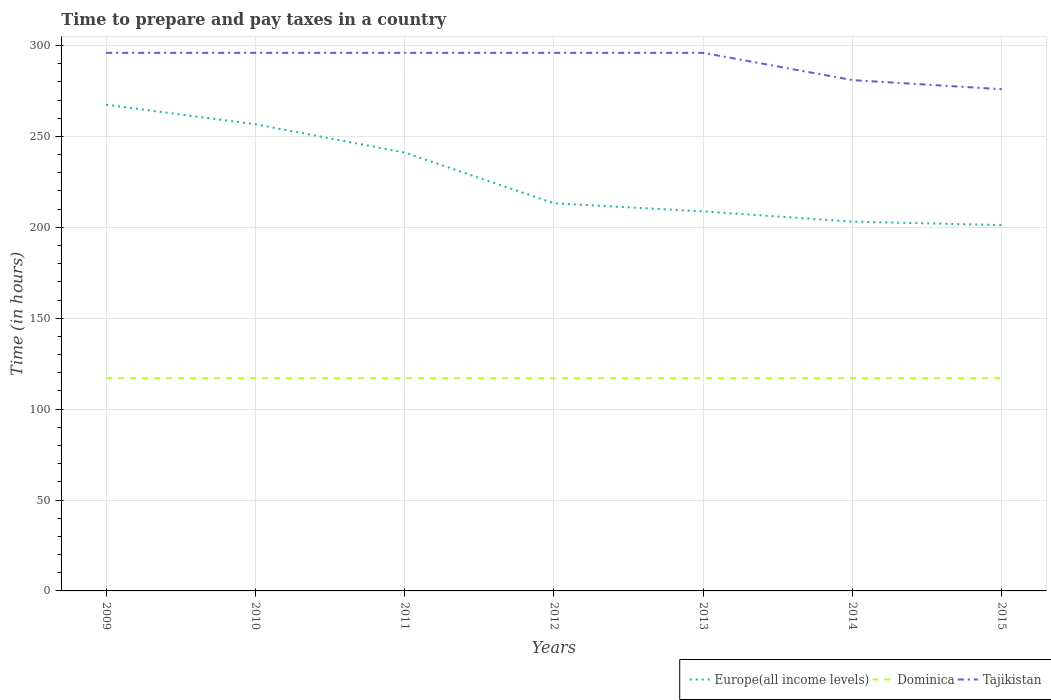How many different coloured lines are there?
Your answer should be very brief. 3. Does the line corresponding to Tajikistan intersect with the line corresponding to Dominica?
Your response must be concise. No. Across all years, what is the maximum number of hours required to prepare and pay taxes in Europe(all income levels)?
Your answer should be compact. 201.25. In which year was the number of hours required to prepare and pay taxes in Europe(all income levels) maximum?
Offer a terse response. 2015. What is the total number of hours required to prepare and pay taxes in Tajikistan in the graph?
Your response must be concise. 20. What is the difference between the highest and the second highest number of hours required to prepare and pay taxes in Tajikistan?
Make the answer very short. 20. How many lines are there?
Your answer should be compact. 3. Are the values on the major ticks of Y-axis written in scientific E-notation?
Your answer should be compact. No. Where does the legend appear in the graph?
Your answer should be very brief. Bottom right. What is the title of the graph?
Make the answer very short. Time to prepare and pay taxes in a country. What is the label or title of the X-axis?
Your answer should be compact. Years. What is the label or title of the Y-axis?
Make the answer very short. Time (in hours). What is the Time (in hours) of Europe(all income levels) in 2009?
Give a very brief answer. 267.45. What is the Time (in hours) of Dominica in 2009?
Give a very brief answer. 117. What is the Time (in hours) in Tajikistan in 2009?
Offer a very short reply. 296. What is the Time (in hours) of Europe(all income levels) in 2010?
Your response must be concise. 256.72. What is the Time (in hours) of Dominica in 2010?
Offer a very short reply. 117. What is the Time (in hours) in Tajikistan in 2010?
Ensure brevity in your answer.  296. What is the Time (in hours) in Europe(all income levels) in 2011?
Provide a short and direct response. 241.15. What is the Time (in hours) of Dominica in 2011?
Make the answer very short. 117. What is the Time (in hours) of Tajikistan in 2011?
Your response must be concise. 296. What is the Time (in hours) in Europe(all income levels) in 2012?
Offer a very short reply. 213.24. What is the Time (in hours) in Dominica in 2012?
Your answer should be compact. 117. What is the Time (in hours) in Tajikistan in 2012?
Your answer should be compact. 296. What is the Time (in hours) of Europe(all income levels) in 2013?
Your response must be concise. 208.78. What is the Time (in hours) in Dominica in 2013?
Your answer should be compact. 117. What is the Time (in hours) of Tajikistan in 2013?
Offer a very short reply. 296. What is the Time (in hours) in Europe(all income levels) in 2014?
Provide a succinct answer. 203.14. What is the Time (in hours) of Dominica in 2014?
Your answer should be very brief. 117. What is the Time (in hours) in Tajikistan in 2014?
Your answer should be compact. 281. What is the Time (in hours) of Europe(all income levels) in 2015?
Provide a short and direct response. 201.25. What is the Time (in hours) of Dominica in 2015?
Provide a succinct answer. 117. What is the Time (in hours) of Tajikistan in 2015?
Ensure brevity in your answer.  276. Across all years, what is the maximum Time (in hours) of Europe(all income levels)?
Provide a succinct answer. 267.45. Across all years, what is the maximum Time (in hours) of Dominica?
Give a very brief answer. 117. Across all years, what is the maximum Time (in hours) of Tajikistan?
Your response must be concise. 296. Across all years, what is the minimum Time (in hours) of Europe(all income levels)?
Provide a succinct answer. 201.25. Across all years, what is the minimum Time (in hours) in Dominica?
Offer a terse response. 117. Across all years, what is the minimum Time (in hours) in Tajikistan?
Ensure brevity in your answer.  276. What is the total Time (in hours) of Europe(all income levels) in the graph?
Provide a short and direct response. 1591.73. What is the total Time (in hours) in Dominica in the graph?
Provide a short and direct response. 819. What is the total Time (in hours) of Tajikistan in the graph?
Give a very brief answer. 2037. What is the difference between the Time (in hours) of Europe(all income levels) in 2009 and that in 2010?
Your response must be concise. 10.73. What is the difference between the Time (in hours) of Tajikistan in 2009 and that in 2010?
Provide a short and direct response. 0. What is the difference between the Time (in hours) in Europe(all income levels) in 2009 and that in 2011?
Your response must be concise. 26.3. What is the difference between the Time (in hours) in Dominica in 2009 and that in 2011?
Offer a terse response. 0. What is the difference between the Time (in hours) in Tajikistan in 2009 and that in 2011?
Make the answer very short. 0. What is the difference between the Time (in hours) of Europe(all income levels) in 2009 and that in 2012?
Give a very brief answer. 54.21. What is the difference between the Time (in hours) in Dominica in 2009 and that in 2012?
Ensure brevity in your answer.  0. What is the difference between the Time (in hours) in Tajikistan in 2009 and that in 2012?
Ensure brevity in your answer.  0. What is the difference between the Time (in hours) in Europe(all income levels) in 2009 and that in 2013?
Provide a succinct answer. 58.68. What is the difference between the Time (in hours) in Dominica in 2009 and that in 2013?
Your answer should be very brief. 0. What is the difference between the Time (in hours) in Tajikistan in 2009 and that in 2013?
Your answer should be compact. 0. What is the difference between the Time (in hours) in Europe(all income levels) in 2009 and that in 2014?
Provide a short and direct response. 64.31. What is the difference between the Time (in hours) in Dominica in 2009 and that in 2014?
Offer a very short reply. 0. What is the difference between the Time (in hours) of Tajikistan in 2009 and that in 2014?
Offer a very short reply. 15. What is the difference between the Time (in hours) in Europe(all income levels) in 2009 and that in 2015?
Keep it short and to the point. 66.2. What is the difference between the Time (in hours) of Dominica in 2009 and that in 2015?
Your response must be concise. 0. What is the difference between the Time (in hours) in Europe(all income levels) in 2010 and that in 2011?
Your response must be concise. 15.57. What is the difference between the Time (in hours) in Europe(all income levels) in 2010 and that in 2012?
Keep it short and to the point. 43.48. What is the difference between the Time (in hours) in Tajikistan in 2010 and that in 2012?
Keep it short and to the point. 0. What is the difference between the Time (in hours) in Europe(all income levels) in 2010 and that in 2013?
Offer a very short reply. 47.95. What is the difference between the Time (in hours) of Dominica in 2010 and that in 2013?
Keep it short and to the point. 0. What is the difference between the Time (in hours) of Europe(all income levels) in 2010 and that in 2014?
Give a very brief answer. 53.58. What is the difference between the Time (in hours) in Dominica in 2010 and that in 2014?
Your response must be concise. 0. What is the difference between the Time (in hours) of Europe(all income levels) in 2010 and that in 2015?
Offer a very short reply. 55.47. What is the difference between the Time (in hours) of Dominica in 2010 and that in 2015?
Your response must be concise. 0. What is the difference between the Time (in hours) of Tajikistan in 2010 and that in 2015?
Your answer should be compact. 20. What is the difference between the Time (in hours) in Europe(all income levels) in 2011 and that in 2012?
Offer a terse response. 27.91. What is the difference between the Time (in hours) in Dominica in 2011 and that in 2012?
Your response must be concise. 0. What is the difference between the Time (in hours) of Europe(all income levels) in 2011 and that in 2013?
Offer a very short reply. 32.37. What is the difference between the Time (in hours) in Dominica in 2011 and that in 2013?
Your answer should be compact. 0. What is the difference between the Time (in hours) in Tajikistan in 2011 and that in 2013?
Ensure brevity in your answer.  0. What is the difference between the Time (in hours) of Europe(all income levels) in 2011 and that in 2014?
Provide a short and direct response. 38.01. What is the difference between the Time (in hours) of Europe(all income levels) in 2011 and that in 2015?
Ensure brevity in your answer.  39.9. What is the difference between the Time (in hours) in Dominica in 2011 and that in 2015?
Provide a short and direct response. 0. What is the difference between the Time (in hours) of Tajikistan in 2011 and that in 2015?
Keep it short and to the point. 20. What is the difference between the Time (in hours) in Europe(all income levels) in 2012 and that in 2013?
Provide a succinct answer. 4.46. What is the difference between the Time (in hours) of Tajikistan in 2012 and that in 2013?
Your answer should be very brief. 0. What is the difference between the Time (in hours) of Europe(all income levels) in 2012 and that in 2014?
Provide a short and direct response. 10.1. What is the difference between the Time (in hours) in Dominica in 2012 and that in 2014?
Keep it short and to the point. 0. What is the difference between the Time (in hours) in Tajikistan in 2012 and that in 2014?
Offer a terse response. 15. What is the difference between the Time (in hours) of Europe(all income levels) in 2012 and that in 2015?
Make the answer very short. 11.99. What is the difference between the Time (in hours) of Dominica in 2012 and that in 2015?
Your response must be concise. 0. What is the difference between the Time (in hours) of Tajikistan in 2012 and that in 2015?
Your answer should be compact. 20. What is the difference between the Time (in hours) of Europe(all income levels) in 2013 and that in 2014?
Give a very brief answer. 5.63. What is the difference between the Time (in hours) in Tajikistan in 2013 and that in 2014?
Provide a succinct answer. 15. What is the difference between the Time (in hours) of Europe(all income levels) in 2013 and that in 2015?
Your answer should be compact. 7.52. What is the difference between the Time (in hours) in Dominica in 2013 and that in 2015?
Keep it short and to the point. 0. What is the difference between the Time (in hours) in Tajikistan in 2013 and that in 2015?
Offer a terse response. 20. What is the difference between the Time (in hours) of Europe(all income levels) in 2014 and that in 2015?
Your answer should be very brief. 1.89. What is the difference between the Time (in hours) of Tajikistan in 2014 and that in 2015?
Offer a terse response. 5. What is the difference between the Time (in hours) of Europe(all income levels) in 2009 and the Time (in hours) of Dominica in 2010?
Offer a terse response. 150.45. What is the difference between the Time (in hours) of Europe(all income levels) in 2009 and the Time (in hours) of Tajikistan in 2010?
Provide a succinct answer. -28.55. What is the difference between the Time (in hours) of Dominica in 2009 and the Time (in hours) of Tajikistan in 2010?
Make the answer very short. -179. What is the difference between the Time (in hours) in Europe(all income levels) in 2009 and the Time (in hours) in Dominica in 2011?
Your answer should be very brief. 150.45. What is the difference between the Time (in hours) of Europe(all income levels) in 2009 and the Time (in hours) of Tajikistan in 2011?
Provide a short and direct response. -28.55. What is the difference between the Time (in hours) in Dominica in 2009 and the Time (in hours) in Tajikistan in 2011?
Keep it short and to the point. -179. What is the difference between the Time (in hours) of Europe(all income levels) in 2009 and the Time (in hours) of Dominica in 2012?
Your response must be concise. 150.45. What is the difference between the Time (in hours) in Europe(all income levels) in 2009 and the Time (in hours) in Tajikistan in 2012?
Your answer should be compact. -28.55. What is the difference between the Time (in hours) of Dominica in 2009 and the Time (in hours) of Tajikistan in 2012?
Your answer should be very brief. -179. What is the difference between the Time (in hours) in Europe(all income levels) in 2009 and the Time (in hours) in Dominica in 2013?
Your answer should be very brief. 150.45. What is the difference between the Time (in hours) in Europe(all income levels) in 2009 and the Time (in hours) in Tajikistan in 2013?
Provide a short and direct response. -28.55. What is the difference between the Time (in hours) of Dominica in 2009 and the Time (in hours) of Tajikistan in 2013?
Ensure brevity in your answer.  -179. What is the difference between the Time (in hours) in Europe(all income levels) in 2009 and the Time (in hours) in Dominica in 2014?
Ensure brevity in your answer.  150.45. What is the difference between the Time (in hours) of Europe(all income levels) in 2009 and the Time (in hours) of Tajikistan in 2014?
Provide a short and direct response. -13.55. What is the difference between the Time (in hours) in Dominica in 2009 and the Time (in hours) in Tajikistan in 2014?
Provide a short and direct response. -164. What is the difference between the Time (in hours) of Europe(all income levels) in 2009 and the Time (in hours) of Dominica in 2015?
Offer a very short reply. 150.45. What is the difference between the Time (in hours) of Europe(all income levels) in 2009 and the Time (in hours) of Tajikistan in 2015?
Keep it short and to the point. -8.55. What is the difference between the Time (in hours) in Dominica in 2009 and the Time (in hours) in Tajikistan in 2015?
Keep it short and to the point. -159. What is the difference between the Time (in hours) of Europe(all income levels) in 2010 and the Time (in hours) of Dominica in 2011?
Provide a short and direct response. 139.72. What is the difference between the Time (in hours) of Europe(all income levels) in 2010 and the Time (in hours) of Tajikistan in 2011?
Offer a very short reply. -39.28. What is the difference between the Time (in hours) of Dominica in 2010 and the Time (in hours) of Tajikistan in 2011?
Ensure brevity in your answer.  -179. What is the difference between the Time (in hours) in Europe(all income levels) in 2010 and the Time (in hours) in Dominica in 2012?
Give a very brief answer. 139.72. What is the difference between the Time (in hours) of Europe(all income levels) in 2010 and the Time (in hours) of Tajikistan in 2012?
Ensure brevity in your answer.  -39.28. What is the difference between the Time (in hours) in Dominica in 2010 and the Time (in hours) in Tajikistan in 2012?
Offer a very short reply. -179. What is the difference between the Time (in hours) in Europe(all income levels) in 2010 and the Time (in hours) in Dominica in 2013?
Give a very brief answer. 139.72. What is the difference between the Time (in hours) in Europe(all income levels) in 2010 and the Time (in hours) in Tajikistan in 2013?
Your response must be concise. -39.28. What is the difference between the Time (in hours) of Dominica in 2010 and the Time (in hours) of Tajikistan in 2013?
Provide a succinct answer. -179. What is the difference between the Time (in hours) in Europe(all income levels) in 2010 and the Time (in hours) in Dominica in 2014?
Your response must be concise. 139.72. What is the difference between the Time (in hours) in Europe(all income levels) in 2010 and the Time (in hours) in Tajikistan in 2014?
Your response must be concise. -24.28. What is the difference between the Time (in hours) in Dominica in 2010 and the Time (in hours) in Tajikistan in 2014?
Provide a short and direct response. -164. What is the difference between the Time (in hours) of Europe(all income levels) in 2010 and the Time (in hours) of Dominica in 2015?
Your response must be concise. 139.72. What is the difference between the Time (in hours) in Europe(all income levels) in 2010 and the Time (in hours) in Tajikistan in 2015?
Give a very brief answer. -19.28. What is the difference between the Time (in hours) of Dominica in 2010 and the Time (in hours) of Tajikistan in 2015?
Your answer should be very brief. -159. What is the difference between the Time (in hours) of Europe(all income levels) in 2011 and the Time (in hours) of Dominica in 2012?
Provide a succinct answer. 124.15. What is the difference between the Time (in hours) of Europe(all income levels) in 2011 and the Time (in hours) of Tajikistan in 2012?
Give a very brief answer. -54.85. What is the difference between the Time (in hours) in Dominica in 2011 and the Time (in hours) in Tajikistan in 2012?
Offer a terse response. -179. What is the difference between the Time (in hours) of Europe(all income levels) in 2011 and the Time (in hours) of Dominica in 2013?
Your answer should be very brief. 124.15. What is the difference between the Time (in hours) in Europe(all income levels) in 2011 and the Time (in hours) in Tajikistan in 2013?
Provide a short and direct response. -54.85. What is the difference between the Time (in hours) of Dominica in 2011 and the Time (in hours) of Tajikistan in 2013?
Your response must be concise. -179. What is the difference between the Time (in hours) in Europe(all income levels) in 2011 and the Time (in hours) in Dominica in 2014?
Provide a succinct answer. 124.15. What is the difference between the Time (in hours) of Europe(all income levels) in 2011 and the Time (in hours) of Tajikistan in 2014?
Give a very brief answer. -39.85. What is the difference between the Time (in hours) of Dominica in 2011 and the Time (in hours) of Tajikistan in 2014?
Your answer should be compact. -164. What is the difference between the Time (in hours) of Europe(all income levels) in 2011 and the Time (in hours) of Dominica in 2015?
Give a very brief answer. 124.15. What is the difference between the Time (in hours) of Europe(all income levels) in 2011 and the Time (in hours) of Tajikistan in 2015?
Make the answer very short. -34.85. What is the difference between the Time (in hours) in Dominica in 2011 and the Time (in hours) in Tajikistan in 2015?
Keep it short and to the point. -159. What is the difference between the Time (in hours) in Europe(all income levels) in 2012 and the Time (in hours) in Dominica in 2013?
Your response must be concise. 96.24. What is the difference between the Time (in hours) of Europe(all income levels) in 2012 and the Time (in hours) of Tajikistan in 2013?
Make the answer very short. -82.76. What is the difference between the Time (in hours) in Dominica in 2012 and the Time (in hours) in Tajikistan in 2013?
Provide a short and direct response. -179. What is the difference between the Time (in hours) of Europe(all income levels) in 2012 and the Time (in hours) of Dominica in 2014?
Make the answer very short. 96.24. What is the difference between the Time (in hours) of Europe(all income levels) in 2012 and the Time (in hours) of Tajikistan in 2014?
Your answer should be compact. -67.76. What is the difference between the Time (in hours) in Dominica in 2012 and the Time (in hours) in Tajikistan in 2014?
Your answer should be compact. -164. What is the difference between the Time (in hours) in Europe(all income levels) in 2012 and the Time (in hours) in Dominica in 2015?
Ensure brevity in your answer.  96.24. What is the difference between the Time (in hours) in Europe(all income levels) in 2012 and the Time (in hours) in Tajikistan in 2015?
Keep it short and to the point. -62.76. What is the difference between the Time (in hours) of Dominica in 2012 and the Time (in hours) of Tajikistan in 2015?
Offer a terse response. -159. What is the difference between the Time (in hours) of Europe(all income levels) in 2013 and the Time (in hours) of Dominica in 2014?
Make the answer very short. 91.78. What is the difference between the Time (in hours) in Europe(all income levels) in 2013 and the Time (in hours) in Tajikistan in 2014?
Provide a short and direct response. -72.22. What is the difference between the Time (in hours) in Dominica in 2013 and the Time (in hours) in Tajikistan in 2014?
Your response must be concise. -164. What is the difference between the Time (in hours) of Europe(all income levels) in 2013 and the Time (in hours) of Dominica in 2015?
Provide a short and direct response. 91.78. What is the difference between the Time (in hours) of Europe(all income levels) in 2013 and the Time (in hours) of Tajikistan in 2015?
Your answer should be very brief. -67.22. What is the difference between the Time (in hours) in Dominica in 2013 and the Time (in hours) in Tajikistan in 2015?
Your response must be concise. -159. What is the difference between the Time (in hours) of Europe(all income levels) in 2014 and the Time (in hours) of Dominica in 2015?
Your answer should be very brief. 86.14. What is the difference between the Time (in hours) of Europe(all income levels) in 2014 and the Time (in hours) of Tajikistan in 2015?
Make the answer very short. -72.86. What is the difference between the Time (in hours) of Dominica in 2014 and the Time (in hours) of Tajikistan in 2015?
Make the answer very short. -159. What is the average Time (in hours) of Europe(all income levels) per year?
Your answer should be compact. 227.39. What is the average Time (in hours) of Dominica per year?
Provide a succinct answer. 117. What is the average Time (in hours) of Tajikistan per year?
Offer a terse response. 291. In the year 2009, what is the difference between the Time (in hours) of Europe(all income levels) and Time (in hours) of Dominica?
Provide a short and direct response. 150.45. In the year 2009, what is the difference between the Time (in hours) in Europe(all income levels) and Time (in hours) in Tajikistan?
Give a very brief answer. -28.55. In the year 2009, what is the difference between the Time (in hours) of Dominica and Time (in hours) of Tajikistan?
Keep it short and to the point. -179. In the year 2010, what is the difference between the Time (in hours) in Europe(all income levels) and Time (in hours) in Dominica?
Your response must be concise. 139.72. In the year 2010, what is the difference between the Time (in hours) of Europe(all income levels) and Time (in hours) of Tajikistan?
Offer a very short reply. -39.28. In the year 2010, what is the difference between the Time (in hours) of Dominica and Time (in hours) of Tajikistan?
Offer a terse response. -179. In the year 2011, what is the difference between the Time (in hours) in Europe(all income levels) and Time (in hours) in Dominica?
Offer a very short reply. 124.15. In the year 2011, what is the difference between the Time (in hours) of Europe(all income levels) and Time (in hours) of Tajikistan?
Provide a short and direct response. -54.85. In the year 2011, what is the difference between the Time (in hours) in Dominica and Time (in hours) in Tajikistan?
Your answer should be very brief. -179. In the year 2012, what is the difference between the Time (in hours) in Europe(all income levels) and Time (in hours) in Dominica?
Give a very brief answer. 96.24. In the year 2012, what is the difference between the Time (in hours) in Europe(all income levels) and Time (in hours) in Tajikistan?
Ensure brevity in your answer.  -82.76. In the year 2012, what is the difference between the Time (in hours) of Dominica and Time (in hours) of Tajikistan?
Make the answer very short. -179. In the year 2013, what is the difference between the Time (in hours) in Europe(all income levels) and Time (in hours) in Dominica?
Your answer should be very brief. 91.78. In the year 2013, what is the difference between the Time (in hours) in Europe(all income levels) and Time (in hours) in Tajikistan?
Your response must be concise. -87.22. In the year 2013, what is the difference between the Time (in hours) in Dominica and Time (in hours) in Tajikistan?
Make the answer very short. -179. In the year 2014, what is the difference between the Time (in hours) of Europe(all income levels) and Time (in hours) of Dominica?
Your answer should be compact. 86.14. In the year 2014, what is the difference between the Time (in hours) of Europe(all income levels) and Time (in hours) of Tajikistan?
Your answer should be very brief. -77.86. In the year 2014, what is the difference between the Time (in hours) of Dominica and Time (in hours) of Tajikistan?
Provide a short and direct response. -164. In the year 2015, what is the difference between the Time (in hours) of Europe(all income levels) and Time (in hours) of Dominica?
Your answer should be compact. 84.25. In the year 2015, what is the difference between the Time (in hours) in Europe(all income levels) and Time (in hours) in Tajikistan?
Provide a succinct answer. -74.75. In the year 2015, what is the difference between the Time (in hours) in Dominica and Time (in hours) in Tajikistan?
Ensure brevity in your answer.  -159. What is the ratio of the Time (in hours) of Europe(all income levels) in 2009 to that in 2010?
Keep it short and to the point. 1.04. What is the ratio of the Time (in hours) of Dominica in 2009 to that in 2010?
Provide a short and direct response. 1. What is the ratio of the Time (in hours) in Tajikistan in 2009 to that in 2010?
Offer a very short reply. 1. What is the ratio of the Time (in hours) in Europe(all income levels) in 2009 to that in 2011?
Ensure brevity in your answer.  1.11. What is the ratio of the Time (in hours) in Dominica in 2009 to that in 2011?
Your response must be concise. 1. What is the ratio of the Time (in hours) of Europe(all income levels) in 2009 to that in 2012?
Provide a short and direct response. 1.25. What is the ratio of the Time (in hours) in Europe(all income levels) in 2009 to that in 2013?
Ensure brevity in your answer.  1.28. What is the ratio of the Time (in hours) of Europe(all income levels) in 2009 to that in 2014?
Provide a short and direct response. 1.32. What is the ratio of the Time (in hours) of Dominica in 2009 to that in 2014?
Your response must be concise. 1. What is the ratio of the Time (in hours) in Tajikistan in 2009 to that in 2014?
Keep it short and to the point. 1.05. What is the ratio of the Time (in hours) of Europe(all income levels) in 2009 to that in 2015?
Offer a terse response. 1.33. What is the ratio of the Time (in hours) in Dominica in 2009 to that in 2015?
Offer a terse response. 1. What is the ratio of the Time (in hours) in Tajikistan in 2009 to that in 2015?
Provide a short and direct response. 1.07. What is the ratio of the Time (in hours) of Europe(all income levels) in 2010 to that in 2011?
Offer a very short reply. 1.06. What is the ratio of the Time (in hours) of Dominica in 2010 to that in 2011?
Your response must be concise. 1. What is the ratio of the Time (in hours) in Europe(all income levels) in 2010 to that in 2012?
Provide a succinct answer. 1.2. What is the ratio of the Time (in hours) in Tajikistan in 2010 to that in 2012?
Offer a terse response. 1. What is the ratio of the Time (in hours) of Europe(all income levels) in 2010 to that in 2013?
Offer a very short reply. 1.23. What is the ratio of the Time (in hours) in Dominica in 2010 to that in 2013?
Ensure brevity in your answer.  1. What is the ratio of the Time (in hours) of Tajikistan in 2010 to that in 2013?
Make the answer very short. 1. What is the ratio of the Time (in hours) in Europe(all income levels) in 2010 to that in 2014?
Your answer should be compact. 1.26. What is the ratio of the Time (in hours) of Tajikistan in 2010 to that in 2014?
Make the answer very short. 1.05. What is the ratio of the Time (in hours) in Europe(all income levels) in 2010 to that in 2015?
Make the answer very short. 1.28. What is the ratio of the Time (in hours) of Tajikistan in 2010 to that in 2015?
Offer a very short reply. 1.07. What is the ratio of the Time (in hours) in Europe(all income levels) in 2011 to that in 2012?
Your answer should be compact. 1.13. What is the ratio of the Time (in hours) in Dominica in 2011 to that in 2012?
Offer a terse response. 1. What is the ratio of the Time (in hours) of Tajikistan in 2011 to that in 2012?
Give a very brief answer. 1. What is the ratio of the Time (in hours) in Europe(all income levels) in 2011 to that in 2013?
Provide a succinct answer. 1.16. What is the ratio of the Time (in hours) of Tajikistan in 2011 to that in 2013?
Provide a short and direct response. 1. What is the ratio of the Time (in hours) in Europe(all income levels) in 2011 to that in 2014?
Provide a short and direct response. 1.19. What is the ratio of the Time (in hours) of Dominica in 2011 to that in 2014?
Your response must be concise. 1. What is the ratio of the Time (in hours) of Tajikistan in 2011 to that in 2014?
Offer a terse response. 1.05. What is the ratio of the Time (in hours) in Europe(all income levels) in 2011 to that in 2015?
Offer a terse response. 1.2. What is the ratio of the Time (in hours) in Tajikistan in 2011 to that in 2015?
Your answer should be very brief. 1.07. What is the ratio of the Time (in hours) of Europe(all income levels) in 2012 to that in 2013?
Your response must be concise. 1.02. What is the ratio of the Time (in hours) of Tajikistan in 2012 to that in 2013?
Your answer should be compact. 1. What is the ratio of the Time (in hours) of Europe(all income levels) in 2012 to that in 2014?
Give a very brief answer. 1.05. What is the ratio of the Time (in hours) of Dominica in 2012 to that in 2014?
Keep it short and to the point. 1. What is the ratio of the Time (in hours) in Tajikistan in 2012 to that in 2014?
Your response must be concise. 1.05. What is the ratio of the Time (in hours) of Europe(all income levels) in 2012 to that in 2015?
Your response must be concise. 1.06. What is the ratio of the Time (in hours) of Tajikistan in 2012 to that in 2015?
Your answer should be compact. 1.07. What is the ratio of the Time (in hours) in Europe(all income levels) in 2013 to that in 2014?
Ensure brevity in your answer.  1.03. What is the ratio of the Time (in hours) of Tajikistan in 2013 to that in 2014?
Your answer should be compact. 1.05. What is the ratio of the Time (in hours) of Europe(all income levels) in 2013 to that in 2015?
Make the answer very short. 1.04. What is the ratio of the Time (in hours) in Dominica in 2013 to that in 2015?
Your answer should be compact. 1. What is the ratio of the Time (in hours) of Tajikistan in 2013 to that in 2015?
Your response must be concise. 1.07. What is the ratio of the Time (in hours) in Europe(all income levels) in 2014 to that in 2015?
Provide a succinct answer. 1.01. What is the ratio of the Time (in hours) in Tajikistan in 2014 to that in 2015?
Offer a very short reply. 1.02. What is the difference between the highest and the second highest Time (in hours) in Europe(all income levels)?
Your response must be concise. 10.73. What is the difference between the highest and the second highest Time (in hours) of Tajikistan?
Provide a short and direct response. 0. What is the difference between the highest and the lowest Time (in hours) in Europe(all income levels)?
Offer a terse response. 66.2. What is the difference between the highest and the lowest Time (in hours) of Dominica?
Ensure brevity in your answer.  0. 